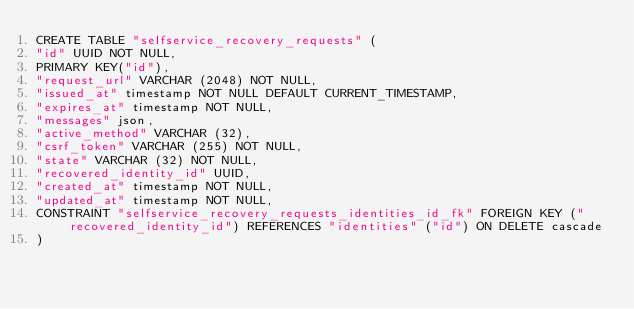<code> <loc_0><loc_0><loc_500><loc_500><_SQL_>CREATE TABLE "selfservice_recovery_requests" (
"id" UUID NOT NULL,
PRIMARY KEY("id"),
"request_url" VARCHAR (2048) NOT NULL,
"issued_at" timestamp NOT NULL DEFAULT CURRENT_TIMESTAMP,
"expires_at" timestamp NOT NULL,
"messages" json,
"active_method" VARCHAR (32),
"csrf_token" VARCHAR (255) NOT NULL,
"state" VARCHAR (32) NOT NULL,
"recovered_identity_id" UUID,
"created_at" timestamp NOT NULL,
"updated_at" timestamp NOT NULL,
CONSTRAINT "selfservice_recovery_requests_identities_id_fk" FOREIGN KEY ("recovered_identity_id") REFERENCES "identities" ("id") ON DELETE cascade
)</code> 